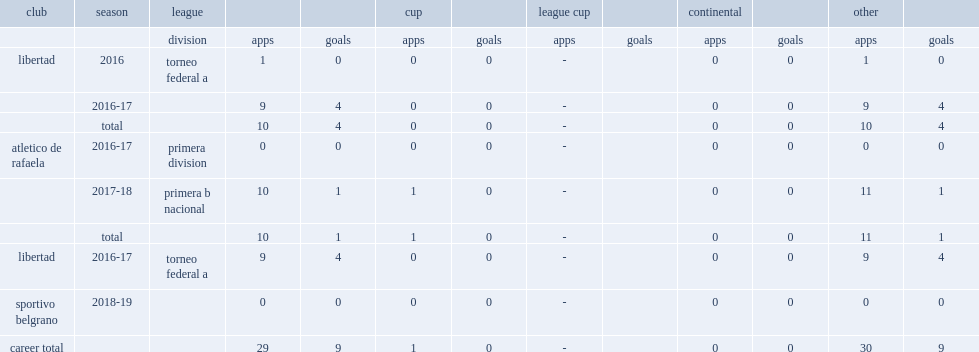Which club did bustos play for in 2016? Libertad. 